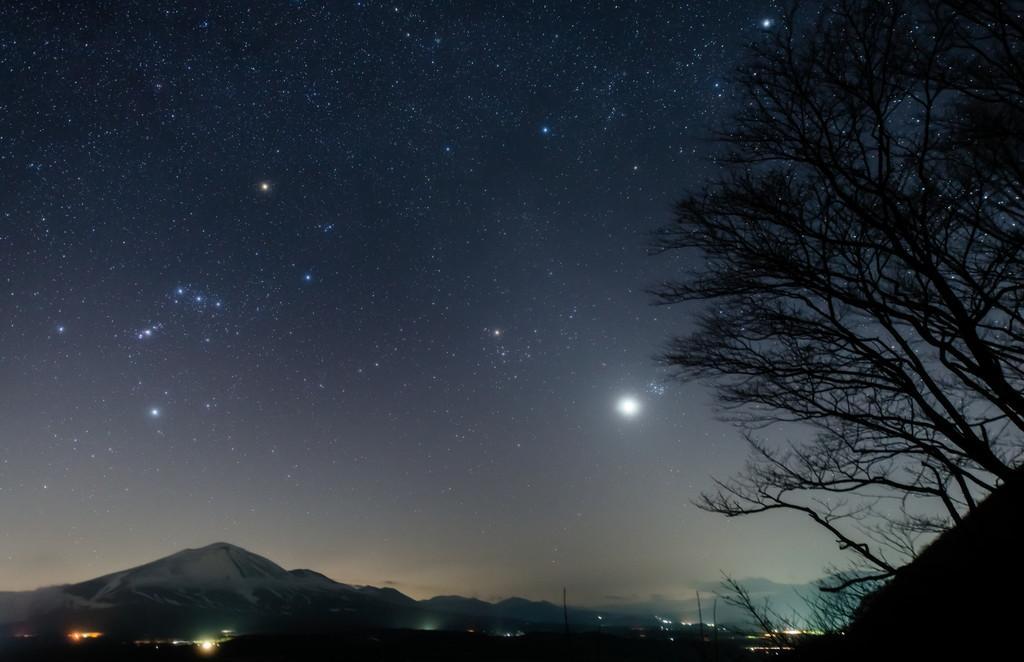How would you summarize this image in a sentence or two? In the picture I can see the deciduous trees on the right side. In the background, I can see the mountains. I can see the moon and stars in the sky. 